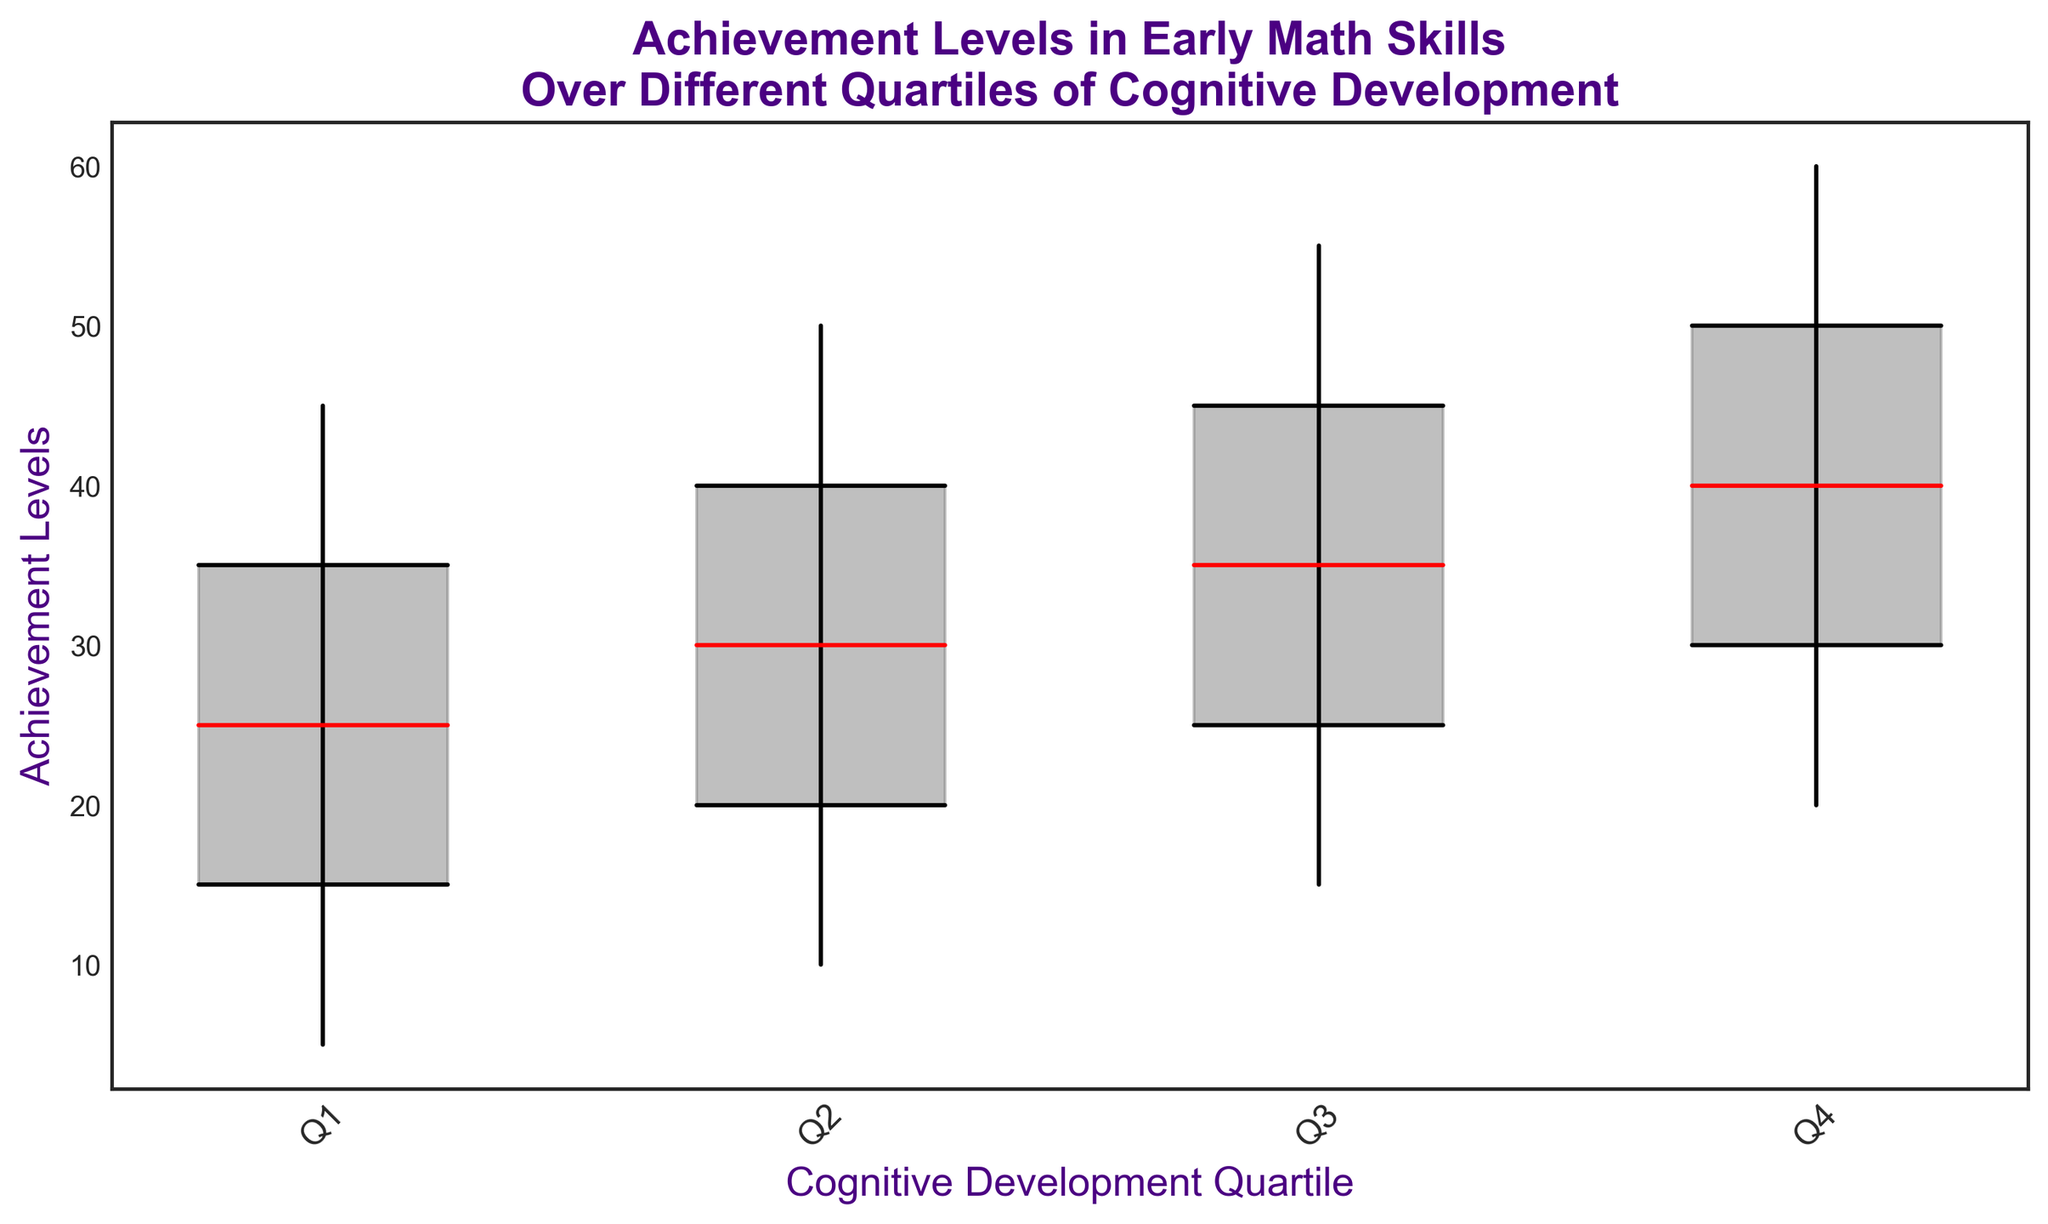What is the median achievement level in Q3? The median achievement level in Q3 is visually represented by the horizontal red line in the Q3 candlestick. It corresponds to the y-axis value of 35.
Answer: 35 Compare the range of achievement levels in Q1 with Q4. Which is larger? The range is the difference between the maximum and minimum values. For Q1, the range is 45 - 5 = 40. For Q4, the range is 60 - 20 = 40. Both ranges are equal.
Answer: Equal What is the interquartile range (IQR) for Q2? The IQR is calculated as the difference between the third quartile (Q3) and the first quartile (Q1). For Q2, this is 40 - 20 = 20.
Answer: 20 Which cognitive development quartile has the highest maximum achievement level? By observing the highest points of the vertical black lines, Q4 has the highest maximum value of 60.
Answer: Q4 What is the difference between the medians of Q1 and Q4? The median for Q1 is 25 and for Q4 is 40. The difference is 40 - 25 = 15.
Answer: 15 Which quartile has the smallest interquartile range (IQR)? The IQR for each quartile is Q3 - Q1. The IQRs are: Q1: 35 - 15 = 20, Q2: 40 - 20 = 20, Q3: 45 - 25 = 20, Q4: 50 - 30 = 20. All quartiles have the same IQR of 20.
Answer: All quartiles Are the medians increasing consistently across quartiles? The medians for each quartile are Q1: 25, Q2: 30, Q3: 35, Q4: 40. The medians are consistently increasing as we move from Q1 to Q4.
Answer: Yes Which development quartile has the narrowest spread from minimum to maximum? The spread is calculated as the max minus the min for each quartile: Q1: 45 - 5 = 40, Q2: 50 - 10 = 40, Q3: 55 - 15 = 40, Q4: 60 - 20 = 40. All quartiles have the same spread of 40.
Answer: All quartiles 